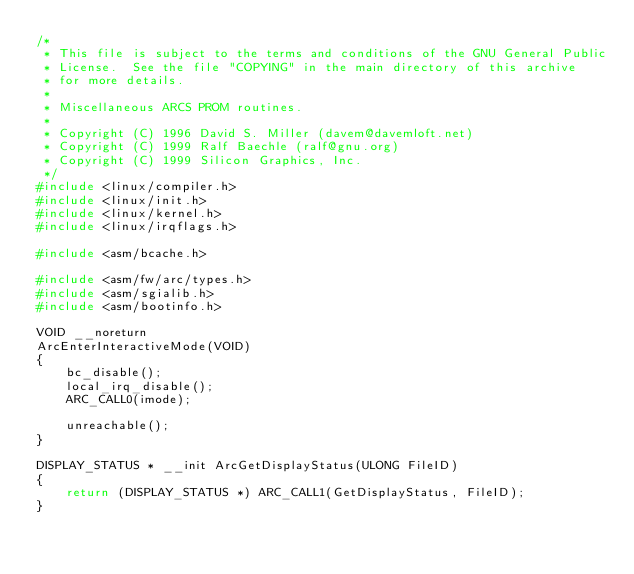<code> <loc_0><loc_0><loc_500><loc_500><_C_>/*
 * This file is subject to the terms and conditions of the GNU General Public
 * License.  See the file "COPYING" in the main directory of this archive
 * for more details.
 *
 * Miscellaneous ARCS PROM routines.
 *
 * Copyright (C) 1996 David S. Miller (davem@davemloft.net)
 * Copyright (C) 1999 Ralf Baechle (ralf@gnu.org)
 * Copyright (C) 1999 Silicon Graphics, Inc.
 */
#include <linux/compiler.h>
#include <linux/init.h>
#include <linux/kernel.h>
#include <linux/irqflags.h>

#include <asm/bcache.h>

#include <asm/fw/arc/types.h>
#include <asm/sgialib.h>
#include <asm/bootinfo.h>

VOID __noreturn
ArcEnterInteractiveMode(VOID)
{
	bc_disable();
	local_irq_disable();
	ARC_CALL0(imode);

	unreachable();
}

DISPLAY_STATUS * __init ArcGetDisplayStatus(ULONG FileID)
{
	return (DISPLAY_STATUS *) ARC_CALL1(GetDisplayStatus, FileID);
}
</code> 